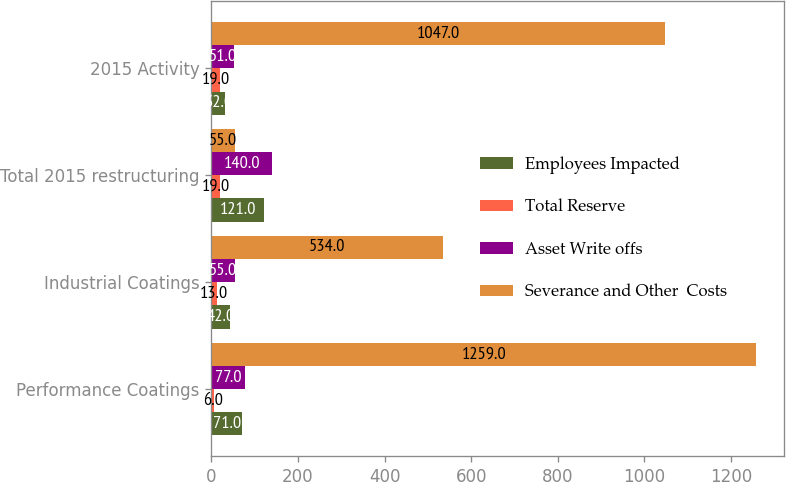Convert chart. <chart><loc_0><loc_0><loc_500><loc_500><stacked_bar_chart><ecel><fcel>Performance Coatings<fcel>Industrial Coatings<fcel>Total 2015 restructuring<fcel>2015 Activity<nl><fcel>Employees Impacted<fcel>71<fcel>42<fcel>121<fcel>32<nl><fcel>Total Reserve<fcel>6<fcel>13<fcel>19<fcel>19<nl><fcel>Asset Write offs<fcel>77<fcel>55<fcel>140<fcel>51<nl><fcel>Severance and Other  Costs<fcel>1259<fcel>534<fcel>55<fcel>1047<nl></chart> 